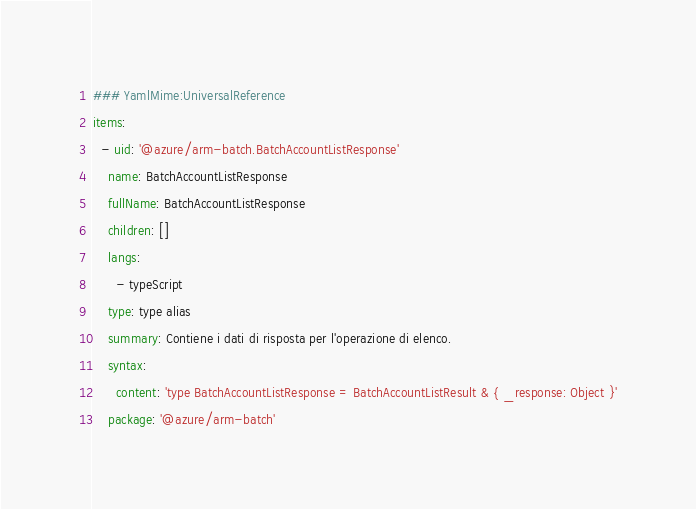Convert code to text. <code><loc_0><loc_0><loc_500><loc_500><_YAML_>### YamlMime:UniversalReference
items:
  - uid: '@azure/arm-batch.BatchAccountListResponse'
    name: BatchAccountListResponse
    fullName: BatchAccountListResponse
    children: []
    langs:
      - typeScript
    type: type alias
    summary: Contiene i dati di risposta per l'operazione di elenco.
    syntax:
      content: 'type BatchAccountListResponse = BatchAccountListResult & { _response: Object }'
    package: '@azure/arm-batch'</code> 